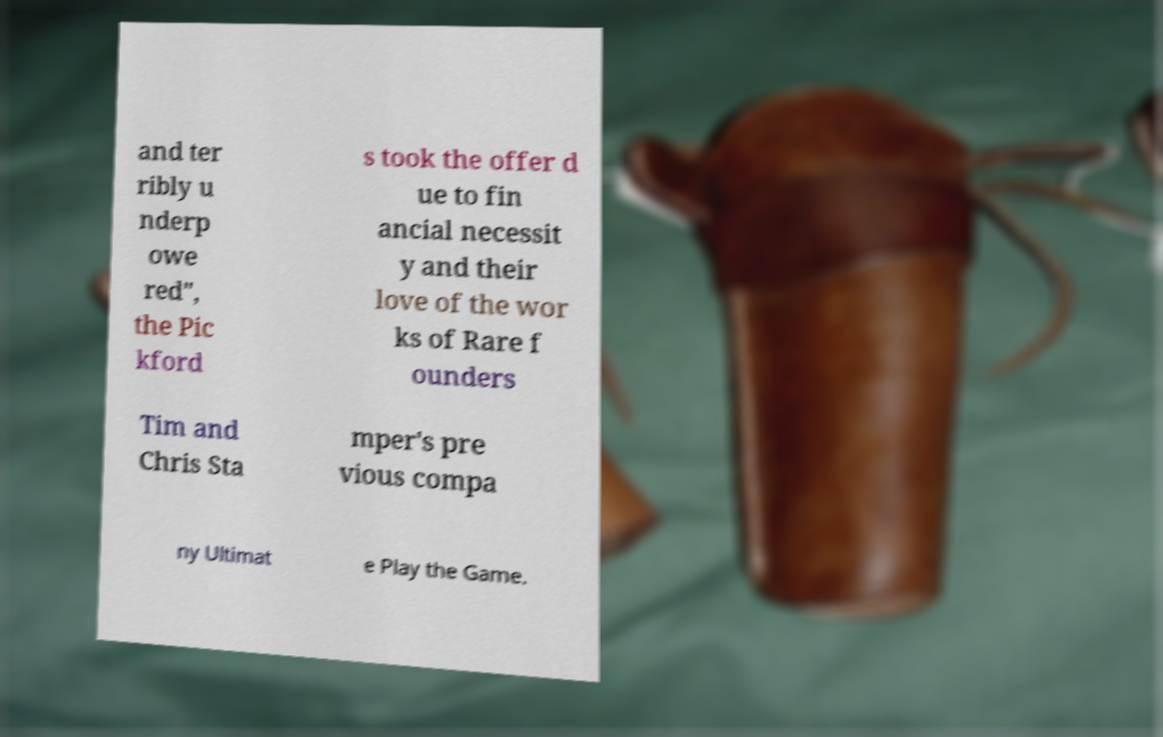Can you accurately transcribe the text from the provided image for me? and ter ribly u nderp owe red", the Pic kford s took the offer d ue to fin ancial necessit y and their love of the wor ks of Rare f ounders Tim and Chris Sta mper's pre vious compa ny Ultimat e Play the Game. 